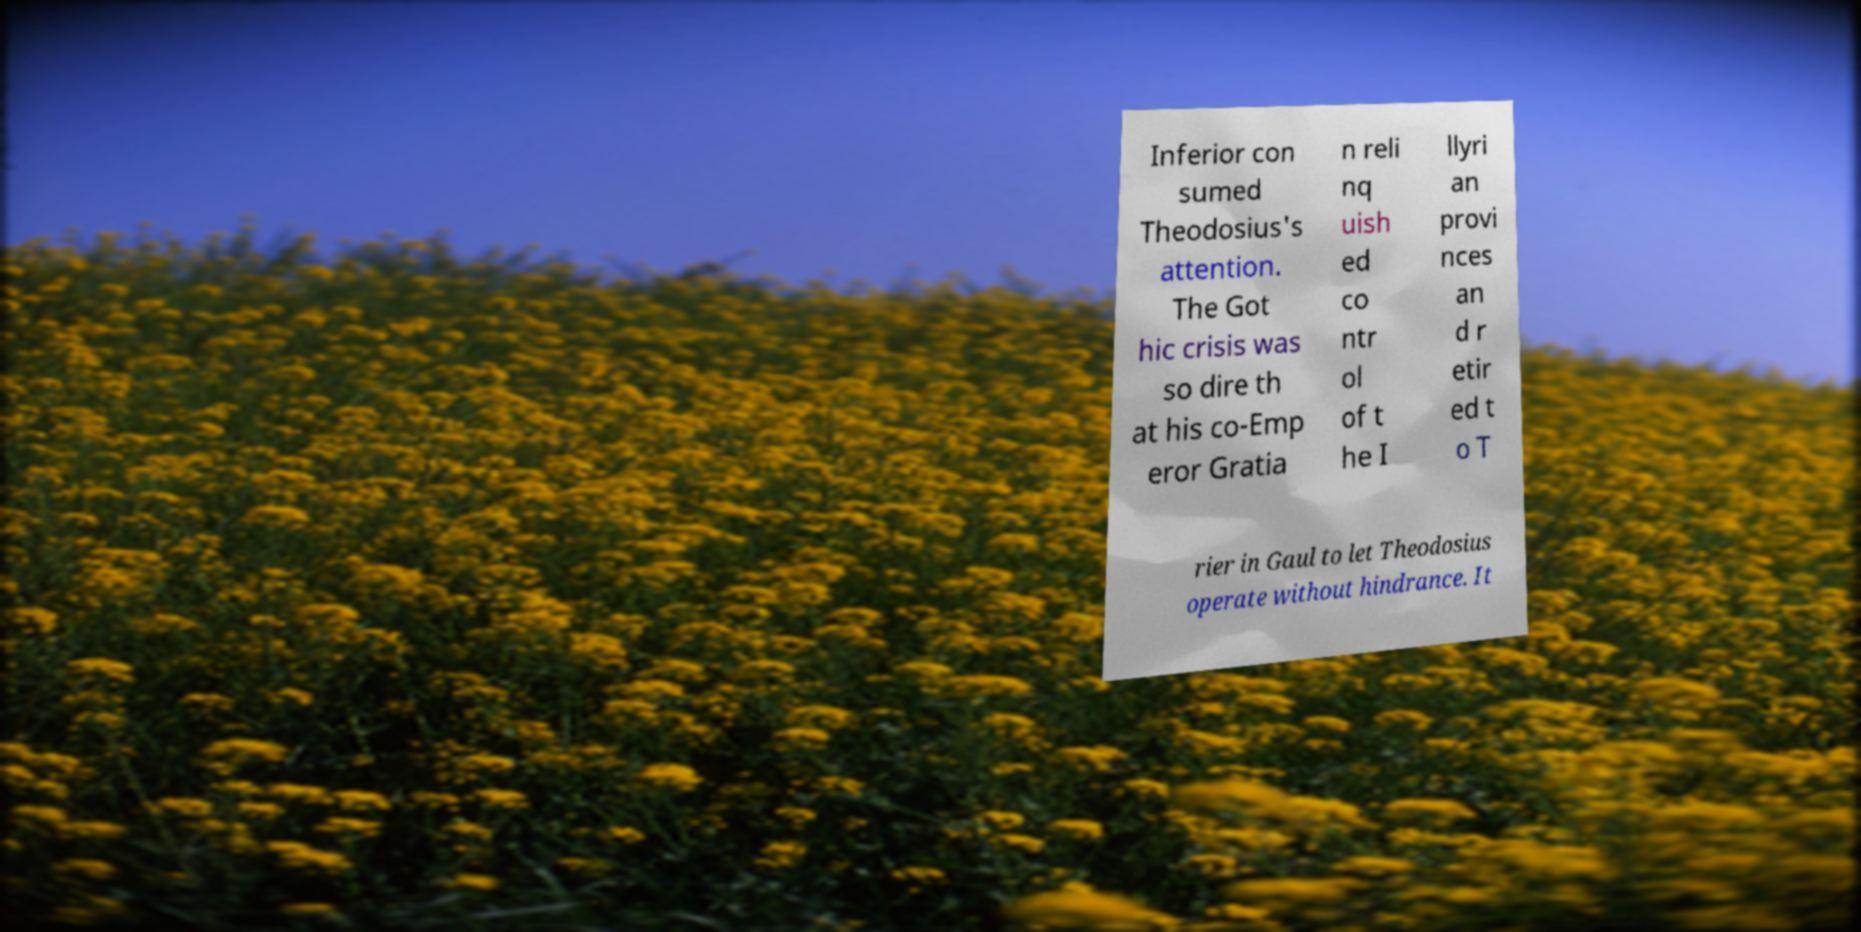Could you assist in decoding the text presented in this image and type it out clearly? Inferior con sumed Theodosius's attention. The Got hic crisis was so dire th at his co-Emp eror Gratia n reli nq uish ed co ntr ol of t he I llyri an provi nces an d r etir ed t o T rier in Gaul to let Theodosius operate without hindrance. It 